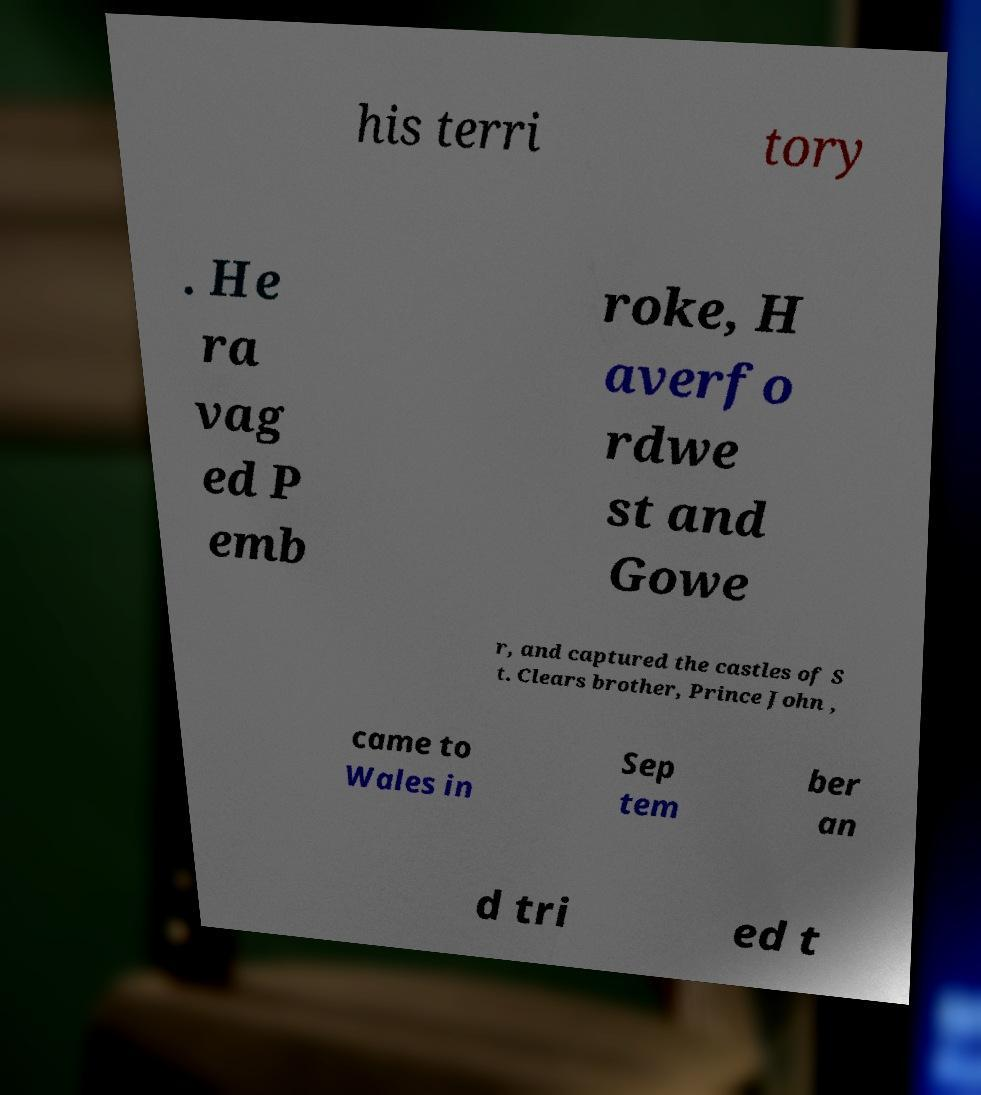For documentation purposes, I need the text within this image transcribed. Could you provide that? his terri tory . He ra vag ed P emb roke, H averfo rdwe st and Gowe r, and captured the castles of S t. Clears brother, Prince John , came to Wales in Sep tem ber an d tri ed t 